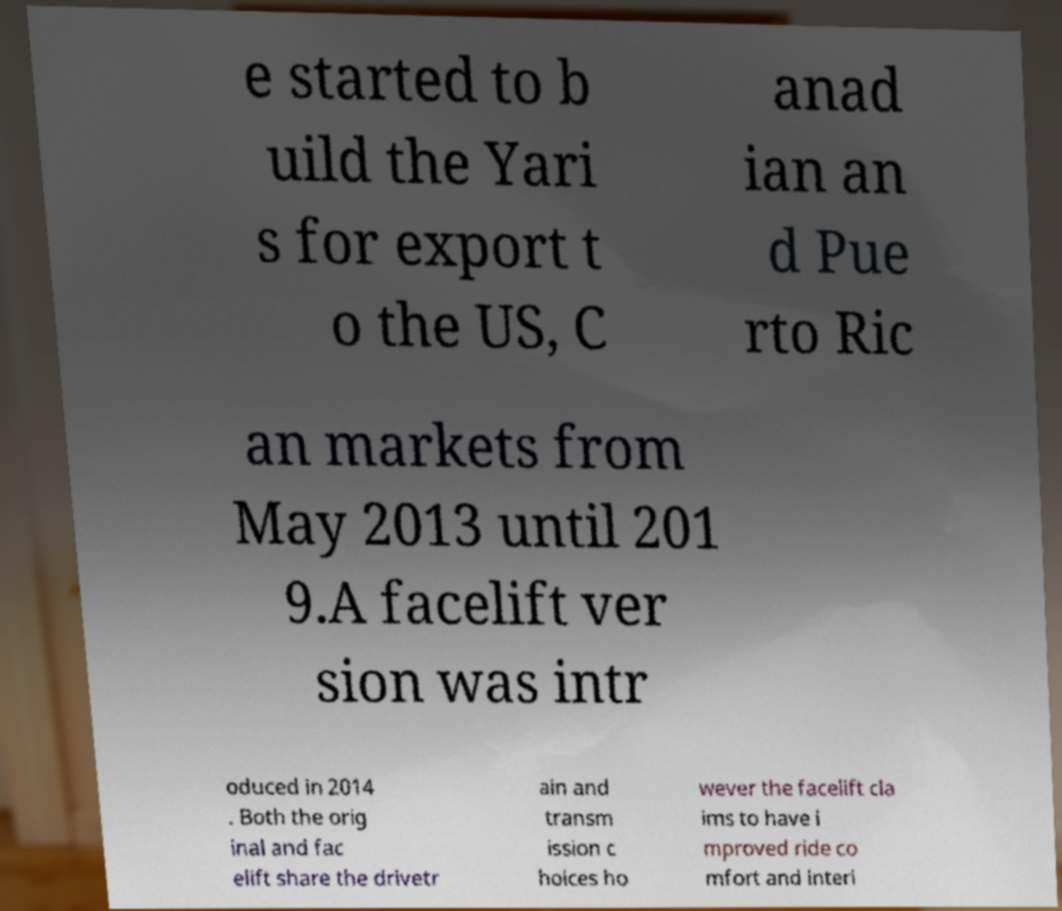Could you extract and type out the text from this image? e started to b uild the Yari s for export t o the US, C anad ian an d Pue rto Ric an markets from May 2013 until 201 9.A facelift ver sion was intr oduced in 2014 . Both the orig inal and fac elift share the drivetr ain and transm ission c hoices ho wever the facelift cla ims to have i mproved ride co mfort and interi 